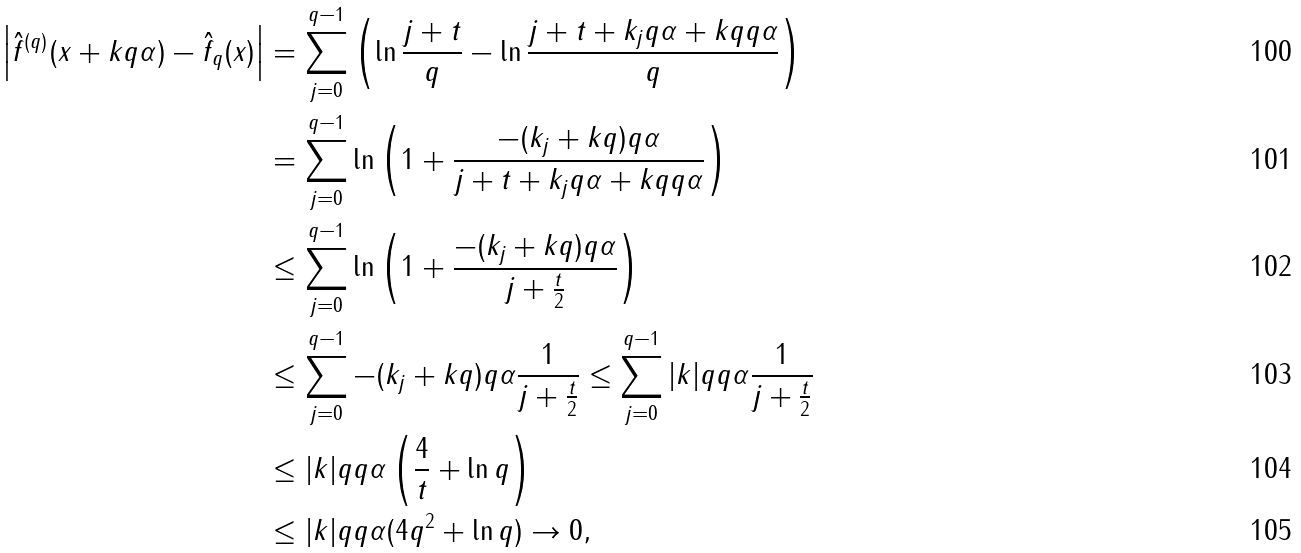Convert formula to latex. <formula><loc_0><loc_0><loc_500><loc_500>\left | \hat { f } ^ { ( q ) } ( x + k \| q \alpha \| ) - \hat { f } _ { q } ( x ) \right | & = \sum _ { j = 0 } ^ { q - 1 } \left ( \ln \frac { j + t } { q } - \ln \frac { j + t + k _ { j } \| q \alpha \| + k q \| q \alpha \| } { q } \right ) \\ & = \sum _ { j = 0 } ^ { q - 1 } \ln \left ( 1 + \frac { - ( k _ { j } + k q ) \| q \alpha \| } { j + t + k _ { j } \| q \alpha \| + k q \| q \alpha \| } \right ) \\ & \leq \sum _ { j = 0 } ^ { q - 1 } \ln \left ( 1 + \frac { - ( k _ { j } + k q ) \| q \alpha \| } { j + \frac { t } { 2 } } \right ) \\ & \leq \sum _ { j = 0 } ^ { q - 1 } - ( k _ { j } + k q ) \| q \alpha \| \frac { 1 } { j + \frac { t } { 2 } } \leq \sum _ { j = 0 } ^ { q - 1 } | k | q \| q \alpha \| \frac { 1 } { j + \frac { t } { 2 } } \\ & \leq | k | q \| q \alpha \| \left ( \frac { 4 } { t } + \ln q \right ) \\ & \leq | k | q \| q \alpha \| ( 4 q ^ { 2 } + \ln q ) \to 0 ,</formula> 